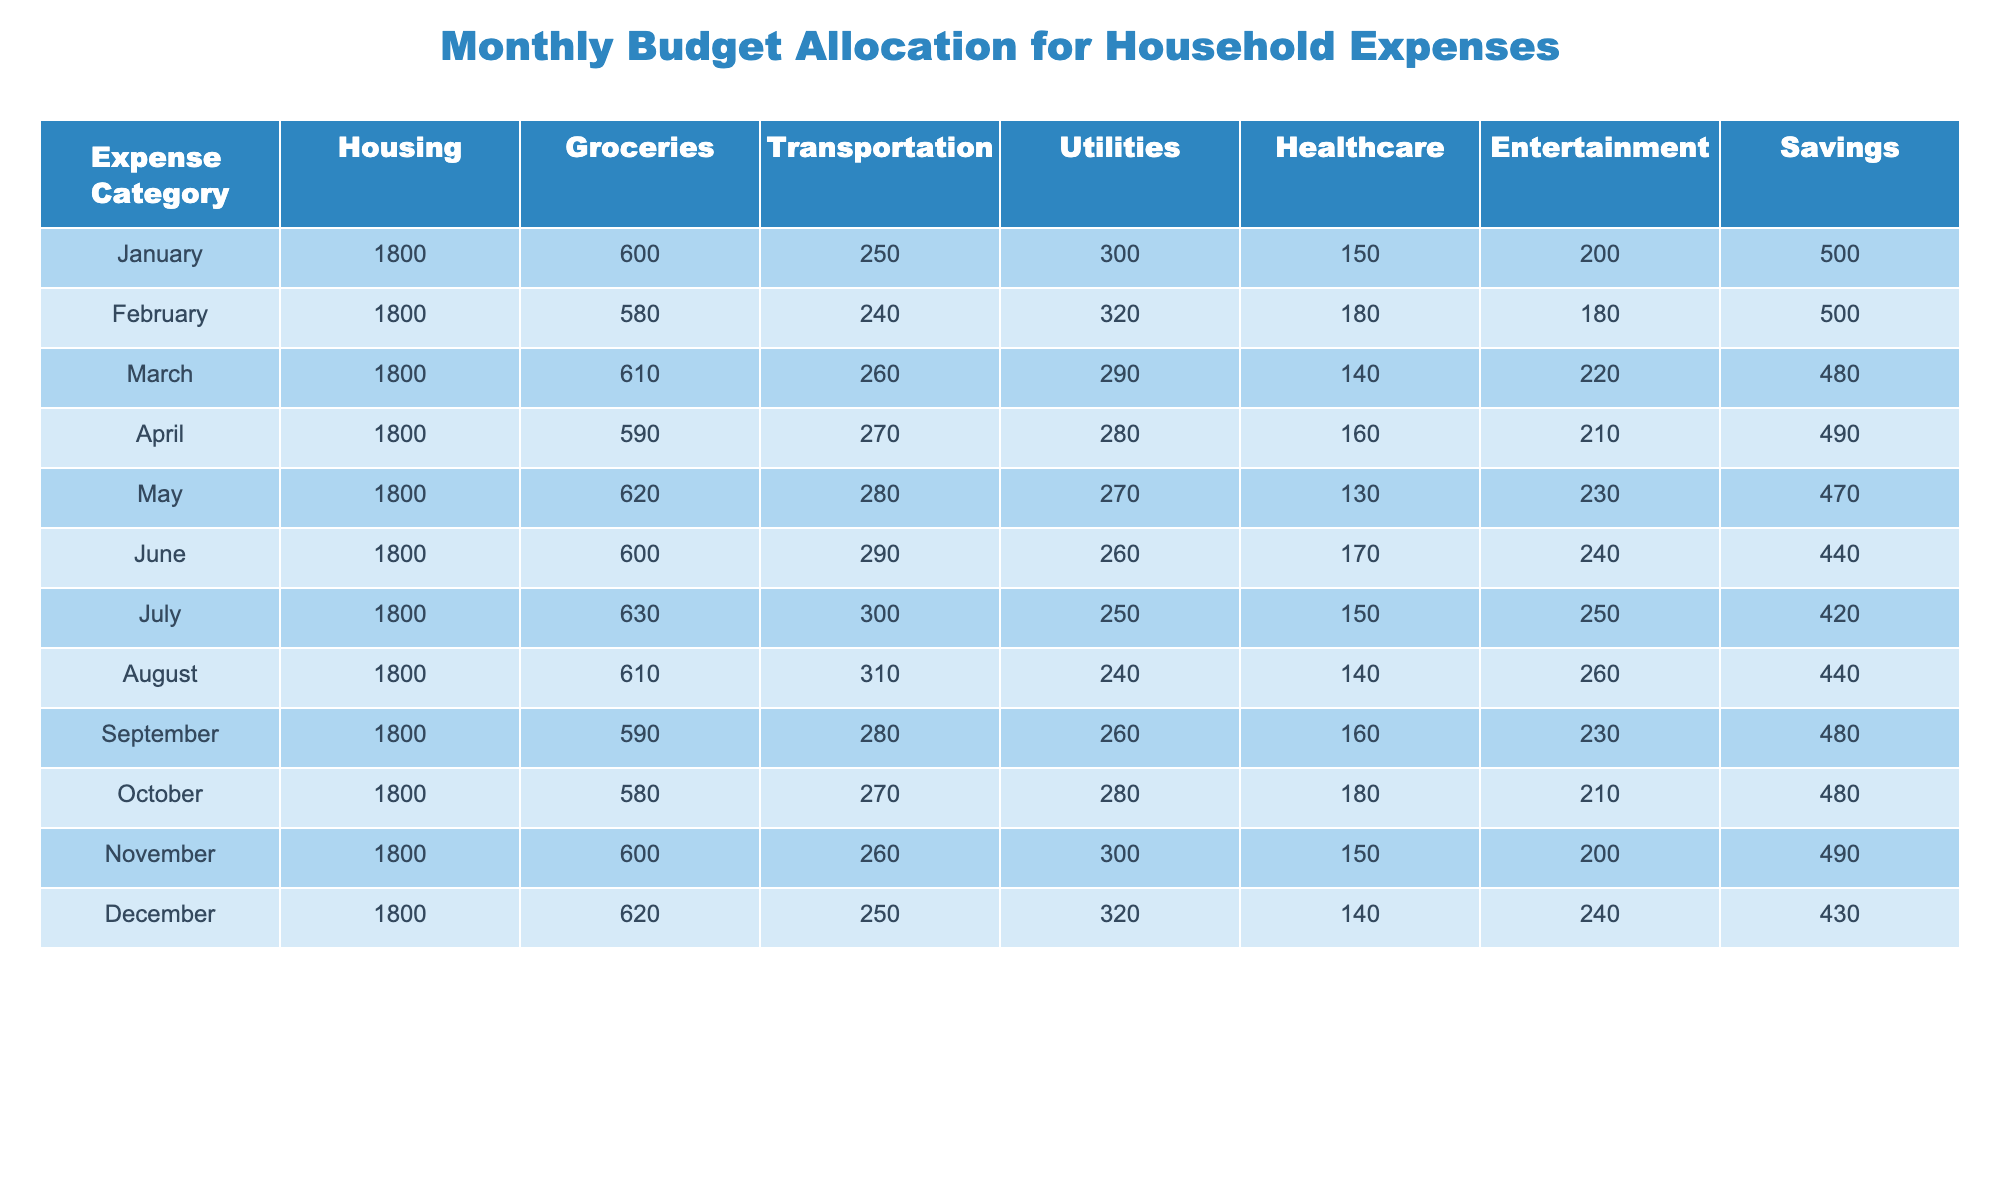What was the total amount allocated for groceries in January? The table shows that in January, the allocated amount for groceries is 600.
Answer: 600 Which month had the highest spending on entertainment? The highest value in the Entertainment column is 260, which occurs in August.
Answer: August What is the average spending on healthcare over the year? The total healthcare spending is (150 + 180 + 140 + 160 + 130 + 170 + 150 + 140 + 160 + 180 + 150 + 140) = 1740. There are 12 months, so the average is 1740 / 12 = 145.
Answer: 145 In which month did savings see the lowest allocation? By looking at the Savings column, the lowest value is 420, which occurs in July.
Answer: July What is the total expense on utilities from January to March combined? The total for utilities is (300 + 320 + 290) = 910 for January, February, and March.
Answer: 910 Did the housing expense change at any point during the year? The table shows that the housing expense remained constant at 1800 each month.
Answer: No What is the difference in groceries spending between the highest and lowest months? The highest groceries spending is 630 in July, and the lowest is 580 in February, so the difference is 630 - 580 = 50.
Answer: 50 Which month had both the lowest utilities expense and healthcare expense? The lowest utilities expense is 240 (in August) and the lowest healthcare expense is 130 (in May). Neither month has both lowest values, indicating they occur in different months.
Answer: No common month What is the sum of total expenses for all categories in December? To get the total for December, add all expenses: (1800 + 620 + 250 + 320 + 140 + 240 + 430) = 2850.
Answer: 2850 What trend can be seen in the allocation of savings from January to December? The savings allocation shows a downward trend overall, starting from 500 in January and decreasing as low as 420 in July, before recovering slightly. The overall trend indicates a fluctuating but generally decreasing pattern towards the end of the year.
Answer: Decreasing trend 